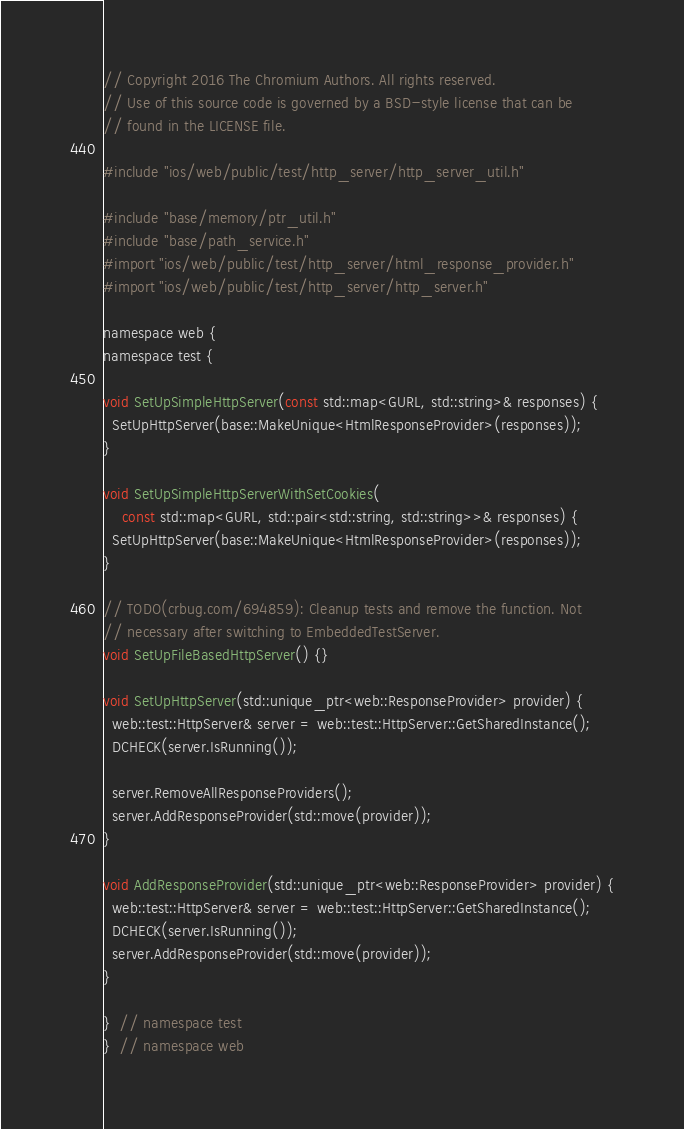<code> <loc_0><loc_0><loc_500><loc_500><_ObjectiveC_>// Copyright 2016 The Chromium Authors. All rights reserved.
// Use of this source code is governed by a BSD-style license that can be
// found in the LICENSE file.

#include "ios/web/public/test/http_server/http_server_util.h"

#include "base/memory/ptr_util.h"
#include "base/path_service.h"
#import "ios/web/public/test/http_server/html_response_provider.h"
#import "ios/web/public/test/http_server/http_server.h"

namespace web {
namespace test {

void SetUpSimpleHttpServer(const std::map<GURL, std::string>& responses) {
  SetUpHttpServer(base::MakeUnique<HtmlResponseProvider>(responses));
}

void SetUpSimpleHttpServerWithSetCookies(
    const std::map<GURL, std::pair<std::string, std::string>>& responses) {
  SetUpHttpServer(base::MakeUnique<HtmlResponseProvider>(responses));
}

// TODO(crbug.com/694859): Cleanup tests and remove the function. Not
// necessary after switching to EmbeddedTestServer.
void SetUpFileBasedHttpServer() {}

void SetUpHttpServer(std::unique_ptr<web::ResponseProvider> provider) {
  web::test::HttpServer& server = web::test::HttpServer::GetSharedInstance();
  DCHECK(server.IsRunning());

  server.RemoveAllResponseProviders();
  server.AddResponseProvider(std::move(provider));
}

void AddResponseProvider(std::unique_ptr<web::ResponseProvider> provider) {
  web::test::HttpServer& server = web::test::HttpServer::GetSharedInstance();
  DCHECK(server.IsRunning());
  server.AddResponseProvider(std::move(provider));
}

}  // namespace test
}  // namespace web
</code> 